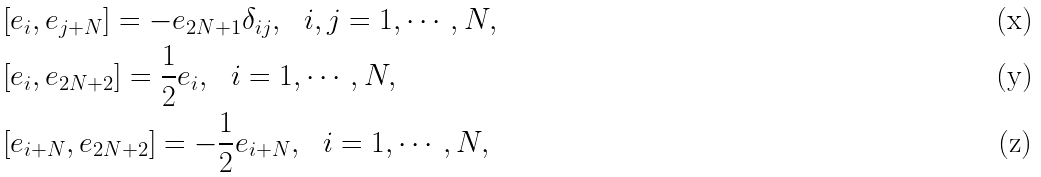<formula> <loc_0><loc_0><loc_500><loc_500>& [ e _ { i } , e _ { j + N } ] = - e _ { 2 N + 1 } \delta _ { i j } , \ \ i , j = 1 , \cdots , N , \\ & [ e _ { i } , e _ { 2 N + 2 } ] = \frac { 1 } { 2 } e _ { i } , \ \ i = 1 , \cdots , N , \\ & [ e _ { i + N } , e _ { 2 N + 2 } ] = - \frac { 1 } { 2 } e _ { i + N } , \ \ i = 1 , \cdots , N ,</formula> 